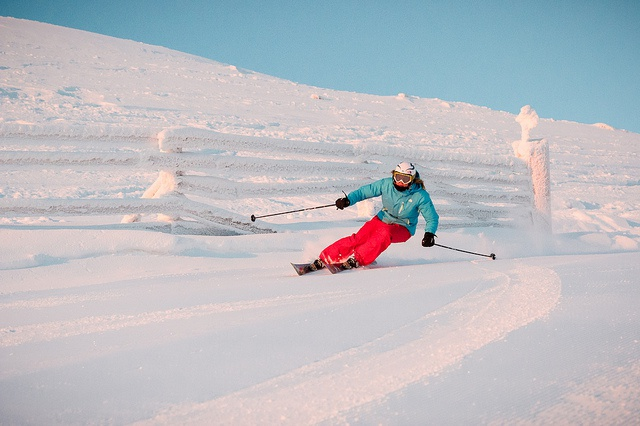Describe the objects in this image and their specific colors. I can see people in teal, red, black, and lightgray tones and skis in teal, black, maroon, gray, and brown tones in this image. 